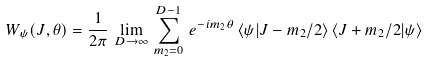Convert formula to latex. <formula><loc_0><loc_0><loc_500><loc_500>W _ { \psi } ( J , \theta ) = \frac { 1 } { 2 \pi } \, \lim _ { D \to \infty } \, \sum _ { m _ { 2 } = 0 } ^ { D - 1 } \, e ^ { - i m _ { 2 } \theta } \, \langle \psi | J - m _ { 2 } / 2 \rangle \, \langle J + m _ { 2 } / 2 | \psi \rangle</formula> 